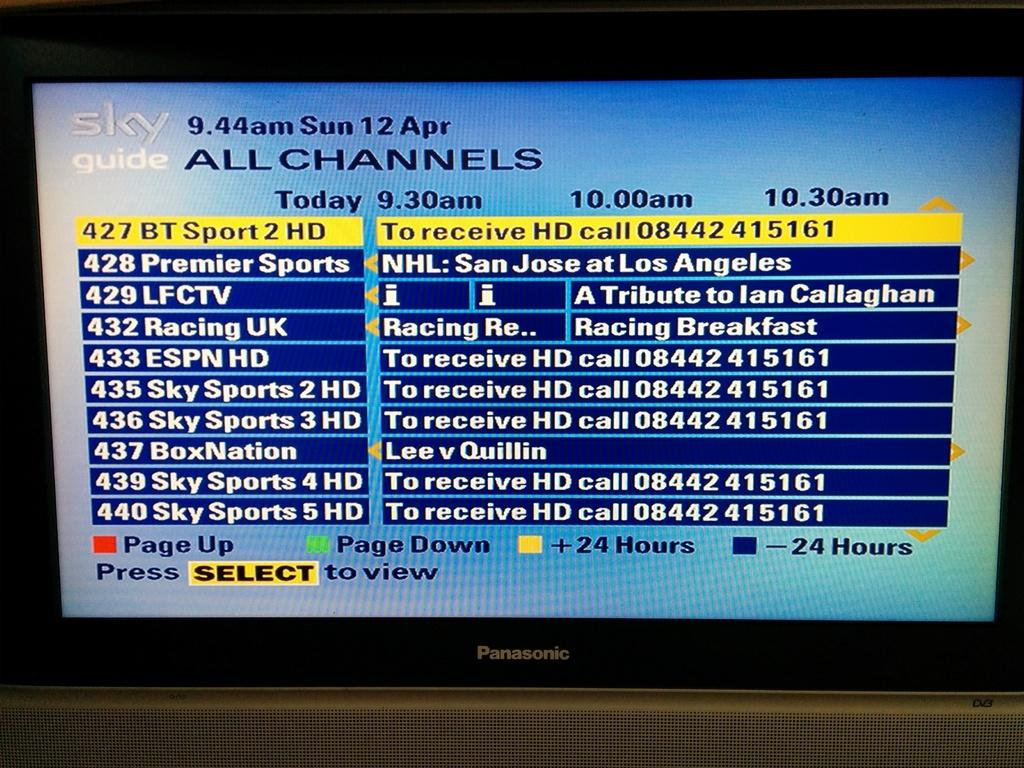<image>
Offer a succinct explanation of the picture presented. A Sky guide that shows an "All channels" screen. 